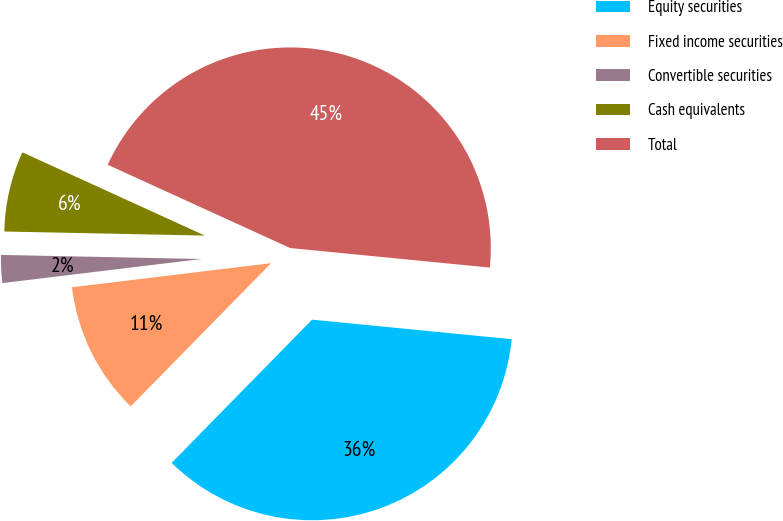Convert chart. <chart><loc_0><loc_0><loc_500><loc_500><pie_chart><fcel>Equity securities<fcel>Fixed income securities<fcel>Convertible securities<fcel>Cash equivalents<fcel>Total<nl><fcel>35.79%<fcel>10.74%<fcel>2.24%<fcel>6.49%<fcel>44.74%<nl></chart> 